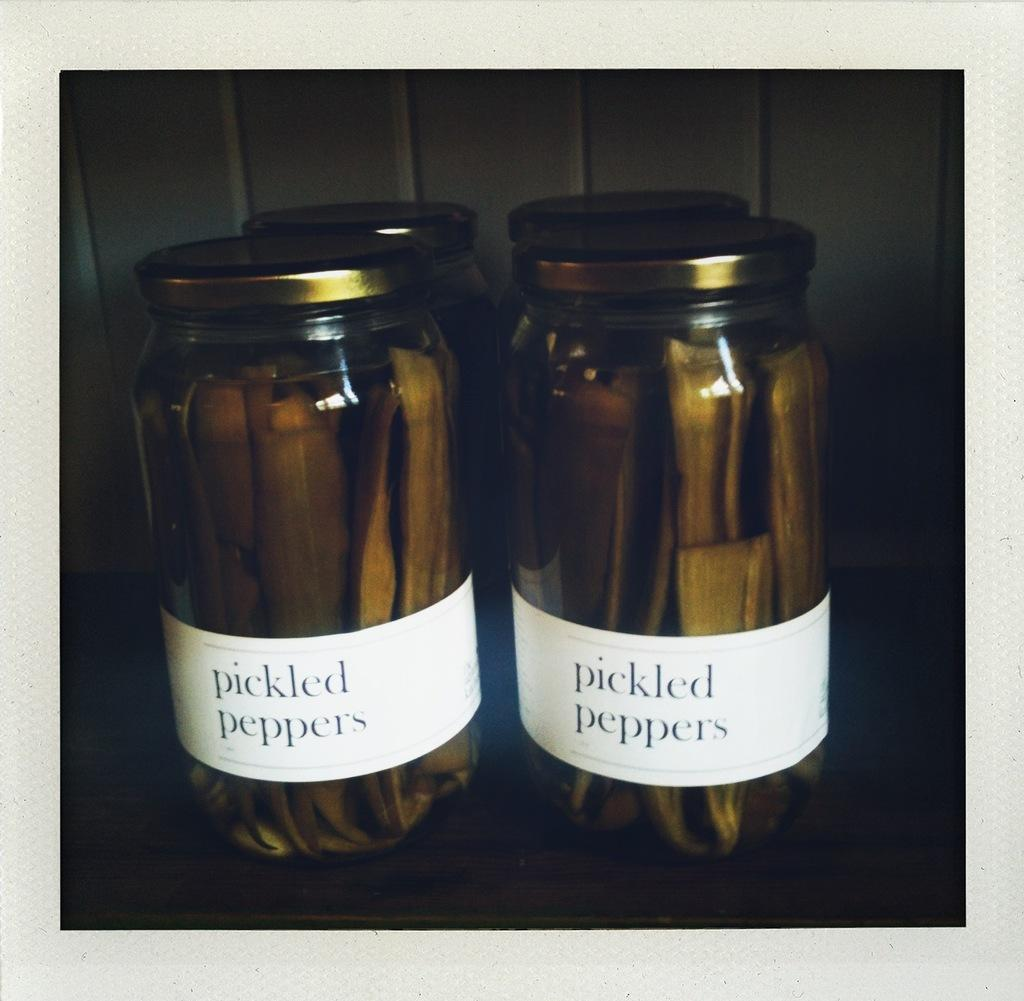<image>
Describe the image concisely. Two jars sitting on a counter with a small white label that reads pickled peppers. 